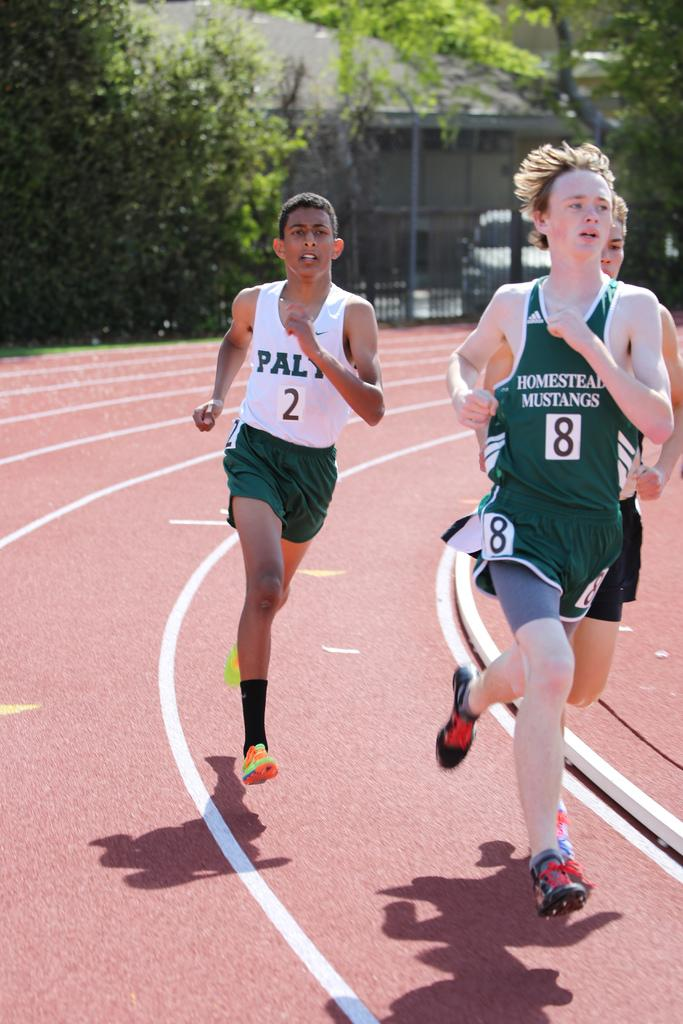<image>
Create a compact narrative representing the image presented. Homestead Mustangs runner number 8 against PALY runner number 2 